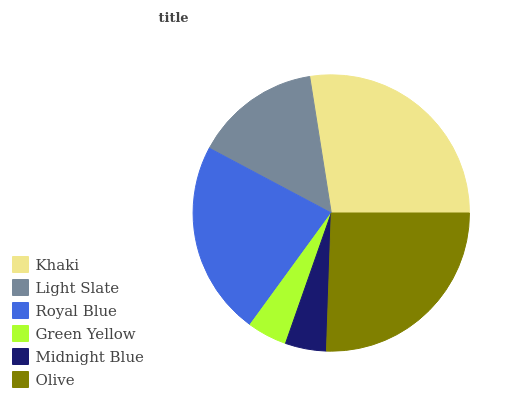Is Green Yellow the minimum?
Answer yes or no. Yes. Is Khaki the maximum?
Answer yes or no. Yes. Is Light Slate the minimum?
Answer yes or no. No. Is Light Slate the maximum?
Answer yes or no. No. Is Khaki greater than Light Slate?
Answer yes or no. Yes. Is Light Slate less than Khaki?
Answer yes or no. Yes. Is Light Slate greater than Khaki?
Answer yes or no. No. Is Khaki less than Light Slate?
Answer yes or no. No. Is Royal Blue the high median?
Answer yes or no. Yes. Is Light Slate the low median?
Answer yes or no. Yes. Is Olive the high median?
Answer yes or no. No. Is Olive the low median?
Answer yes or no. No. 